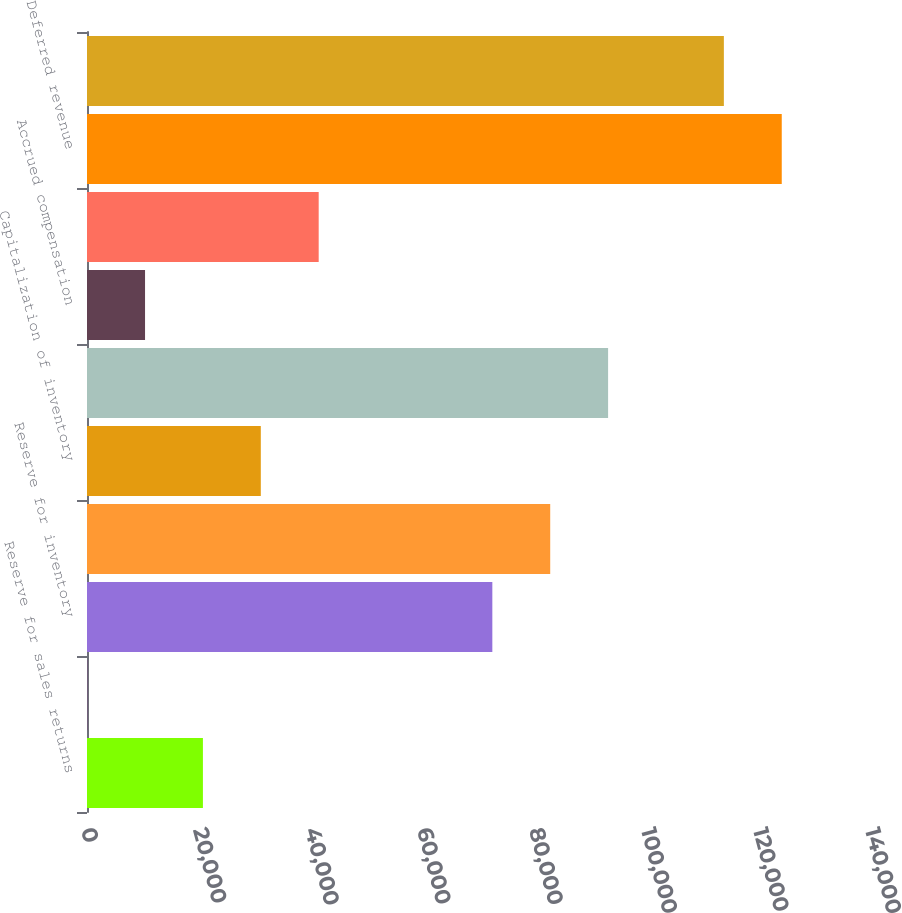Convert chart to OTSL. <chart><loc_0><loc_0><loc_500><loc_500><bar_chart><fcel>Reserve for sales returns<fcel>Reserve for doubtful accounts<fcel>Reserve for inventory<fcel>Reserve for marketing<fcel>Capitalization of inventory<fcel>State franchise tax<fcel>Accrued compensation<fcel>Accrued other liabilities<fcel>Deferred revenue<fcel>Stock-based compensation<nl><fcel>20700.4<fcel>28<fcel>72381.4<fcel>82717.6<fcel>31036.6<fcel>93053.8<fcel>10364.2<fcel>41372.8<fcel>124062<fcel>113726<nl></chart> 